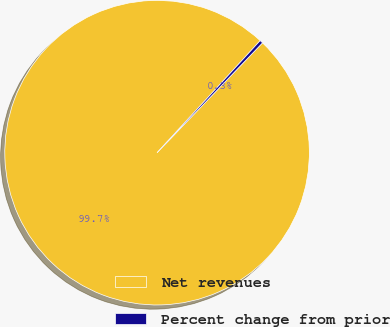<chart> <loc_0><loc_0><loc_500><loc_500><pie_chart><fcel>Net revenues<fcel>Percent change from prior<nl><fcel>99.66%<fcel>0.34%<nl></chart> 